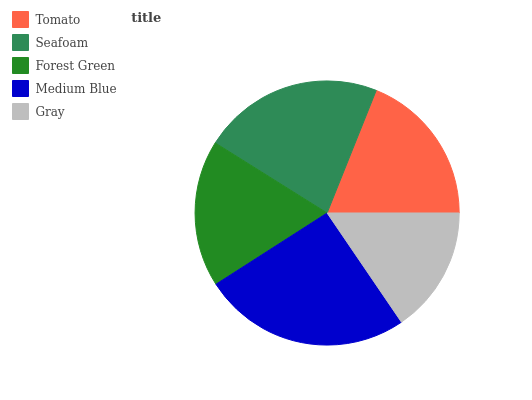Is Gray the minimum?
Answer yes or no. Yes. Is Medium Blue the maximum?
Answer yes or no. Yes. Is Seafoam the minimum?
Answer yes or no. No. Is Seafoam the maximum?
Answer yes or no. No. Is Seafoam greater than Tomato?
Answer yes or no. Yes. Is Tomato less than Seafoam?
Answer yes or no. Yes. Is Tomato greater than Seafoam?
Answer yes or no. No. Is Seafoam less than Tomato?
Answer yes or no. No. Is Tomato the high median?
Answer yes or no. Yes. Is Tomato the low median?
Answer yes or no. Yes. Is Gray the high median?
Answer yes or no. No. Is Gray the low median?
Answer yes or no. No. 